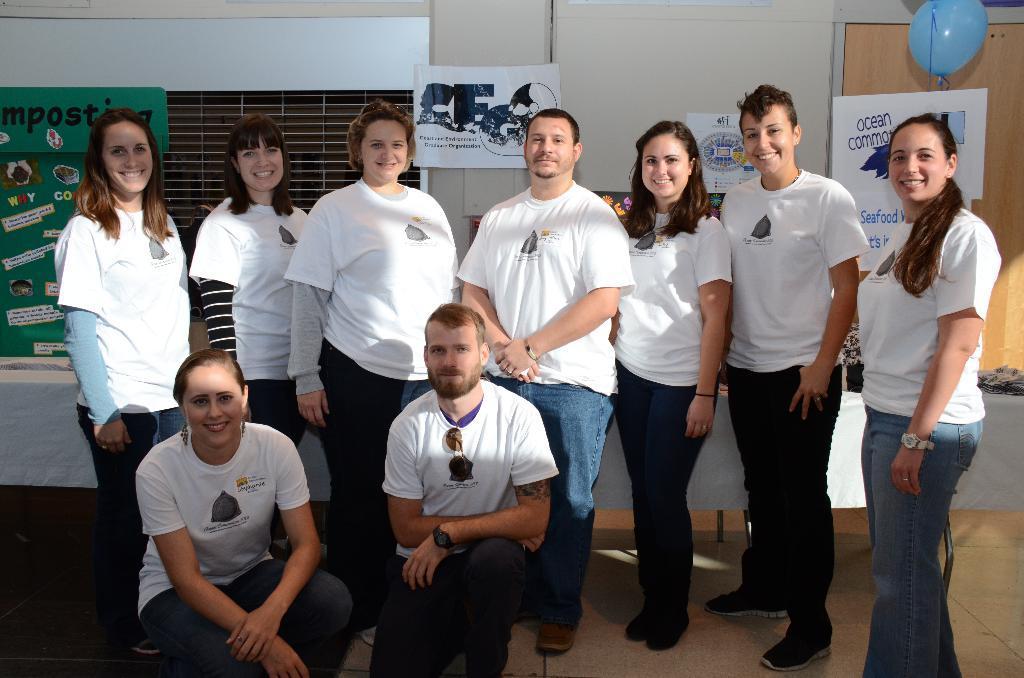In one or two sentences, can you explain what this image depicts? In this picture there are group of people standing and smiling and there are two people on knees. At the back there are boards and there is text on the boards and there is a cupboard and there is a balloon on the cupboard. At the bottom there is an object on the floor. 